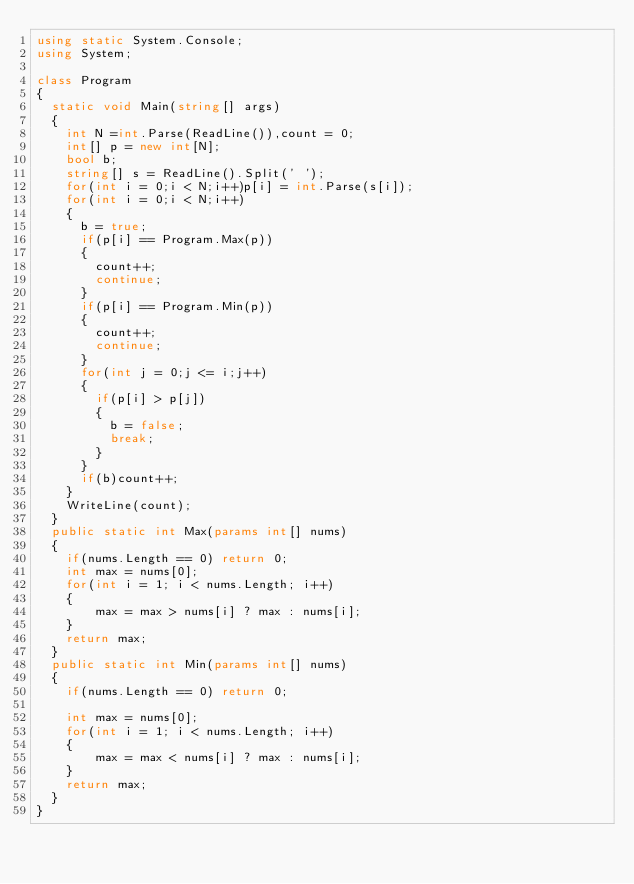Convert code to text. <code><loc_0><loc_0><loc_500><loc_500><_C#_>using static System.Console;
using System;

class Program
{
  static void Main(string[] args)
  {
    int N =int.Parse(ReadLine()),count = 0;
    int[] p = new int[N];
    bool b;
    string[] s = ReadLine().Split(' ');
    for(int i = 0;i < N;i++)p[i] = int.Parse(s[i]);
    for(int i = 0;i < N;i++)
    {
      b = true;
      if(p[i] == Program.Max(p))
      {
        count++;
        continue;
      }
      if(p[i] == Program.Min(p))
      {
        count++;
        continue;
      }
      for(int j = 0;j <= i;j++)
      {
        if(p[i] > p[j])
        {
          b = false;
          break;
        }
      }
      if(b)count++;
    }
    WriteLine(count);
  }
  public static int Max(params int[] nums)
  {
    if(nums.Length == 0) return 0;
    int max = nums[0];
    for(int i = 1; i < nums.Length; i++)
    {
        max = max > nums[i] ? max : nums[i];
    }
    return max;
  }
  public static int Min(params int[] nums)
  {
    if(nums.Length == 0) return 0;

    int max = nums[0];
    for(int i = 1; i < nums.Length; i++)
    {
        max = max < nums[i] ? max : nums[i];
    }
    return max;
  }
}</code> 